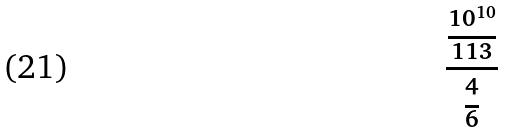<formula> <loc_0><loc_0><loc_500><loc_500>\frac { \frac { 1 0 ^ { 1 0 } } { 1 1 3 } } { \frac { 4 } { 6 } }</formula> 